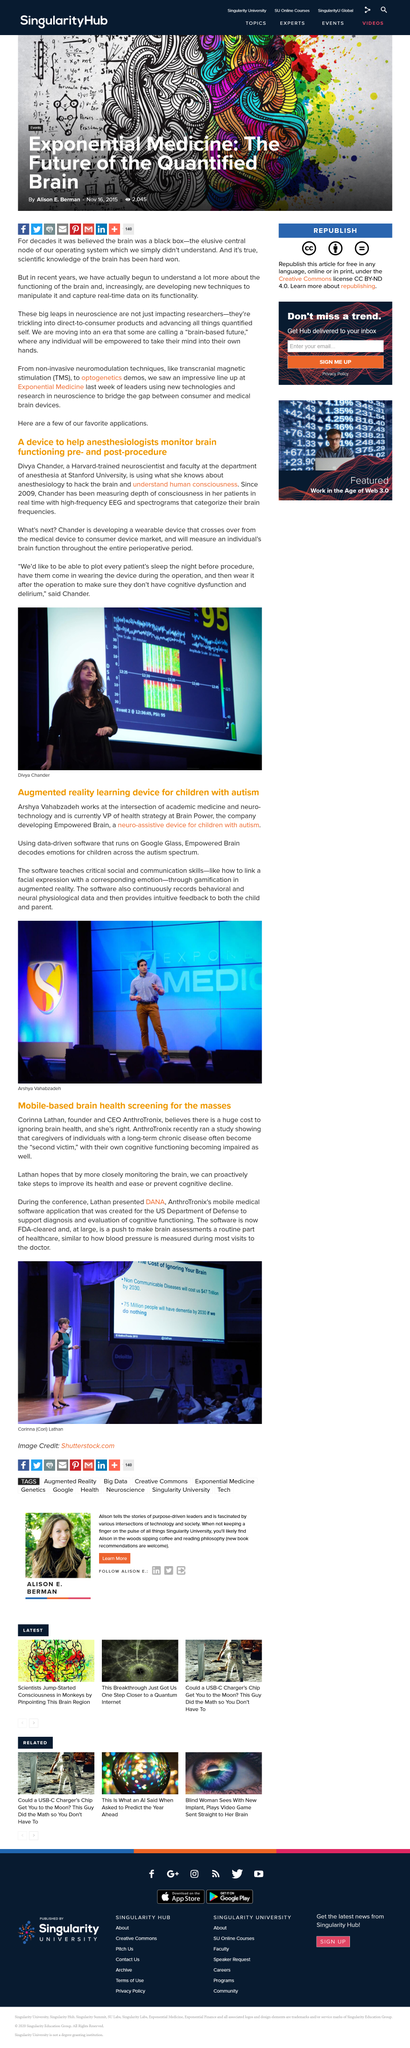Specify some key components in this picture. It is the aim to make brain health a routine aspect of healthcare. Divya Chander received her training in neuroscience from Harvard University. It is common practice to plot the patient's sleep patterns before their procedure, specifically the night before the procedure. Corinna Lathan is the person depicted in the image. The software is designed to teach critical social and communication skills that are essential for success in today's world. 